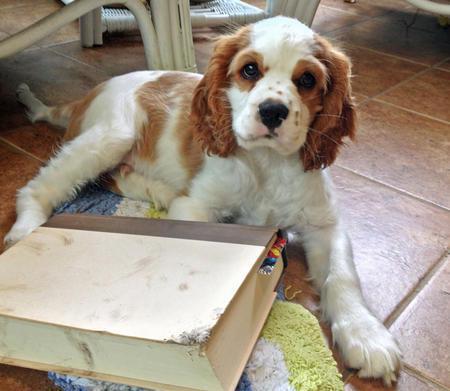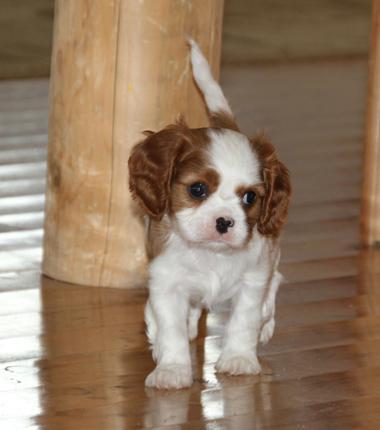The first image is the image on the left, the second image is the image on the right. Assess this claim about the two images: "A dog is lying on the floor with its head up in the left image.". Correct or not? Answer yes or no. Yes. The first image is the image on the left, the second image is the image on the right. Assess this claim about the two images: "An image shows one brown and white dog posed on a brownish tile floor.". Correct or not? Answer yes or no. Yes. 